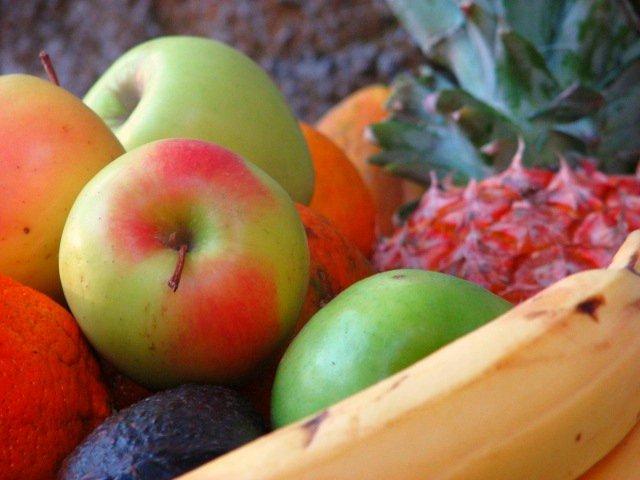Are the apples red?
Be succinct. No. Are the apples green?
Give a very brief answer. Yes. Are there grapes amongst the fruit?
Give a very brief answer. No. What color are the apples?
Quick response, please. Green. How many bananas are in the picture?
Write a very short answer. 1. Are there any bananas in the picture?
Concise answer only. Yes. What kind of fruit is on the left?
Quick response, please. Apple. What color is the pineapple?
Answer briefly. Red. How many apples look rotten?
Answer briefly. 0. 